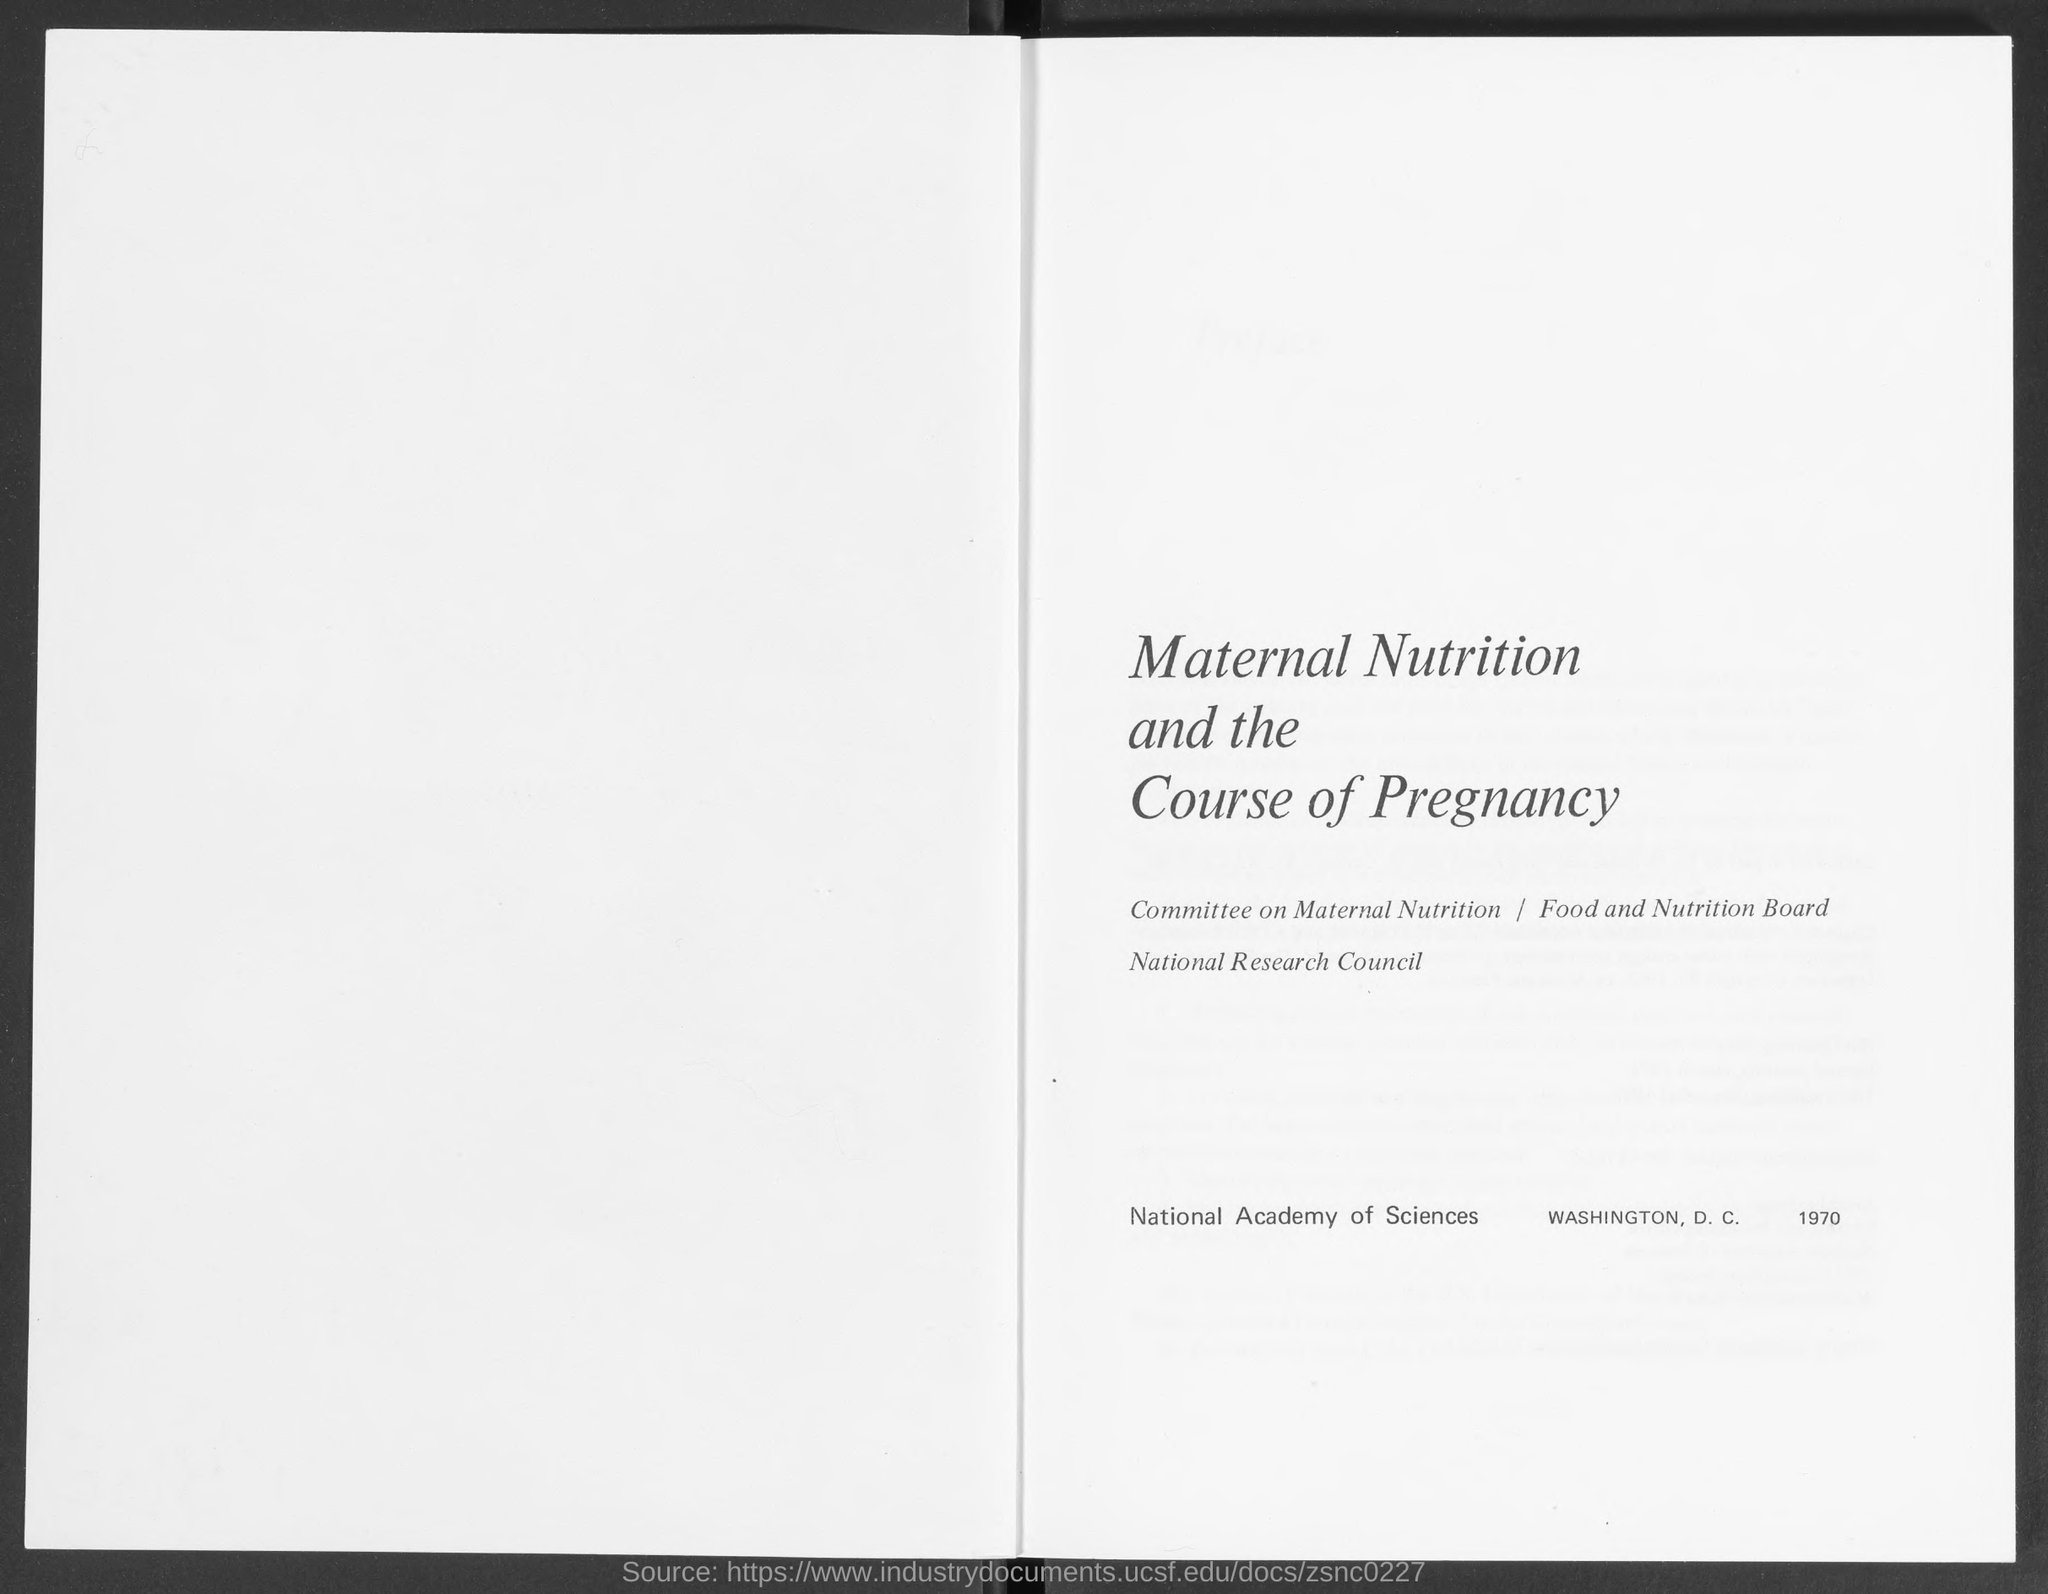What is the heading mentioned in the given page ?
Offer a terse response. Maternal nutrition and the course of pregnancy. What is the name of the committee mentioned in the given page ?
Give a very brief answer. Committee on Maternal Nutrition. What is the name of the council mentioned in the given page ?
Your response must be concise. National research council. 